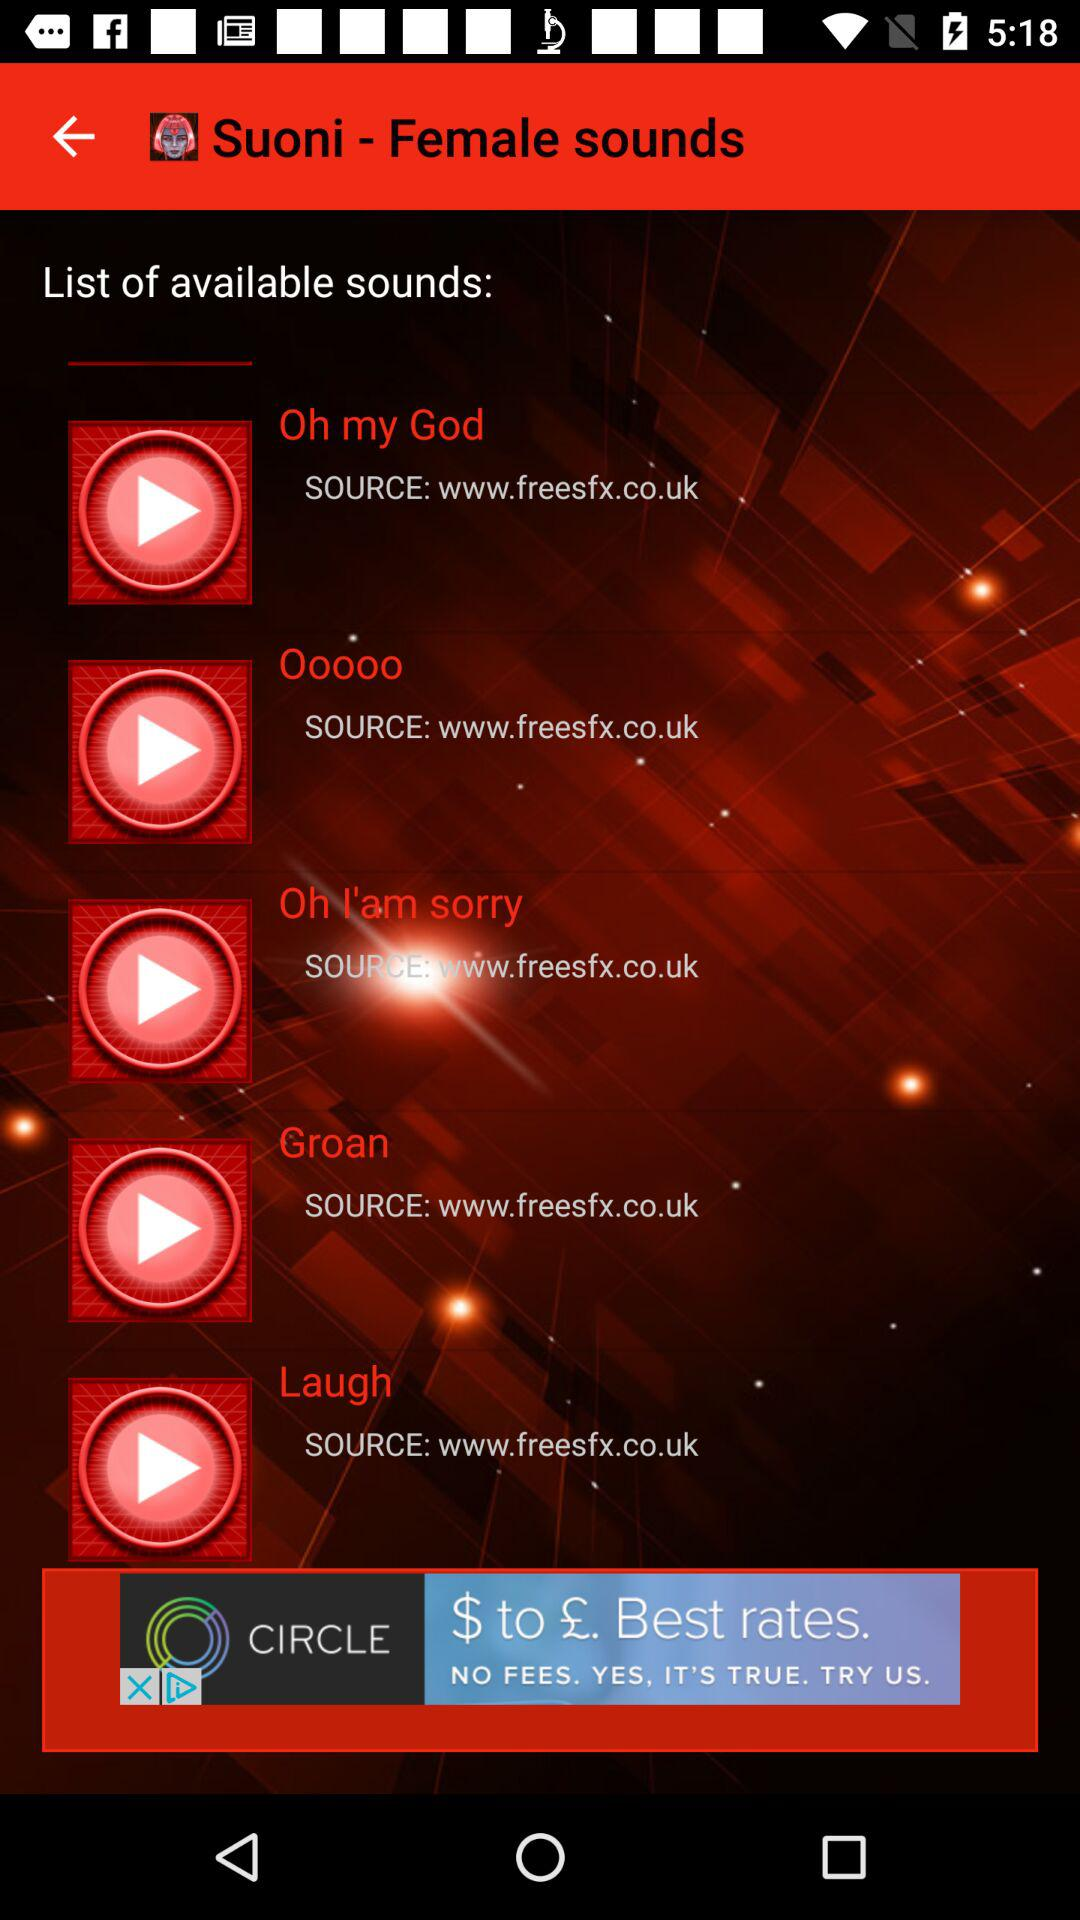What is the source of sound "Oh my God"? The source of sound is www.freesfx.co.uk. 